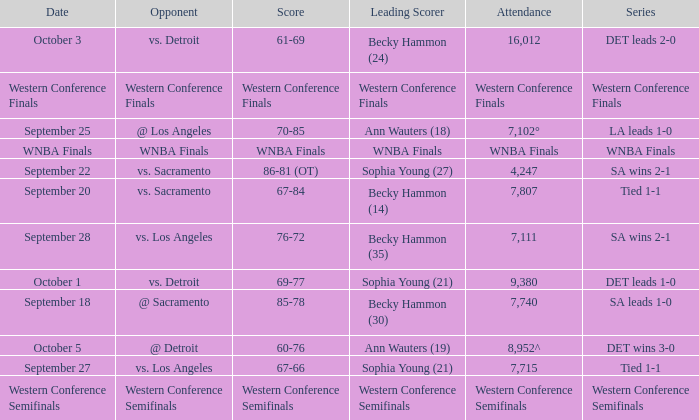Who is the leading scorer of the wnba finals series? WNBA Finals. 